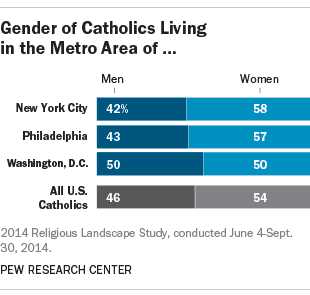Mention a couple of crucial points in this snapshot. The average percentage of men in three cities is smaller than the national average. Washington D.C. has more men than the other cities in the chart. 